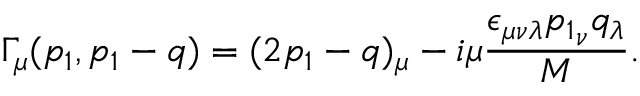Convert formula to latex. <formula><loc_0><loc_0><loc_500><loc_500>\Gamma _ { \mu } ( p _ { 1 } , p _ { 1 } - q ) = ( 2 p _ { 1 } - q ) _ { \mu } - i \mu { \frac { \epsilon _ { \mu \nu \lambda } { p _ { 1 } } _ { \nu } q _ { \lambda } } { M } } .</formula> 